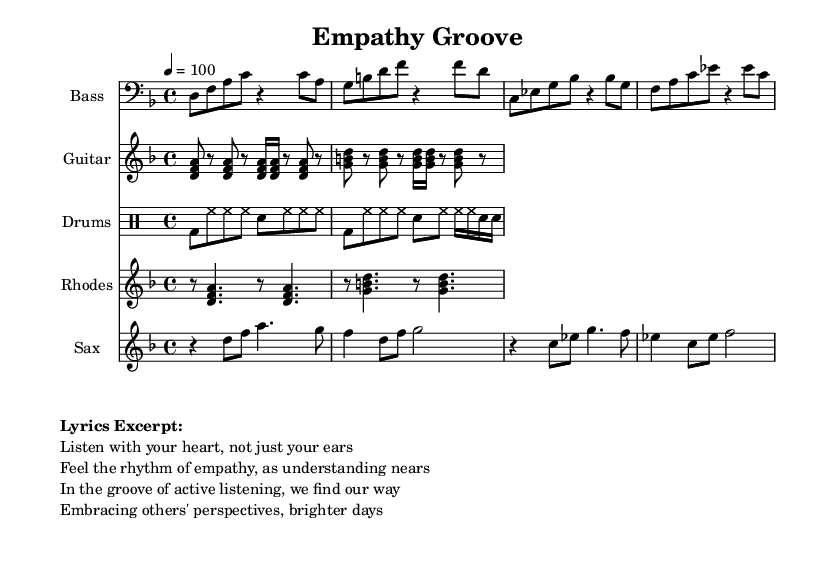What is the key signature of this music? The key signature is D minor, which has one flat (B flat). This can be identified from the key indicated at the beginning of the score, where it states "d \minor".
Answer: D minor What is the time signature of this music? The time signature is 4/4, which indicates that there are four beats in each measure and a quarter note receives one beat. This is confirmed by the "4/4" notation in the score.
Answer: 4/4 What is the tempo marking for this piece? The tempo marking is 100 beats per minute, notated as "4 = 100". This indicates the speed at which the music should be played.
Answer: 100 Which instrument plays the bass line? The bass line is played by the instrument labeled "Bass" in the score. This is indicated by the separate staff with the "Bass" header.
Answer: Bass What rhythmic pattern does the drum part contain? The drum part consists of a bass drum and hi-hat rhythms along with some snare hits, which creates a typical funk groove. This can be deduced from the repeated patterns of "bd", "hh", and "sn" in drum notation.
Answer: Bass and hi-hat How many different instrumental parts are present in this score? There are five instrumental parts: Bass, Guitar, Drums, Rhodes, and Saxophone, each represented by a separate staff. This can be easily counted from the visual layout of the score.
Answer: Five What is a recurring theme expressed in the lyrics? The recurring theme expressed in the lyrics is active listening and empathy. The lyrics mention listening with the heart and embracing others' perspectives, which conveys this theme.
Answer: Active listening and empathy 